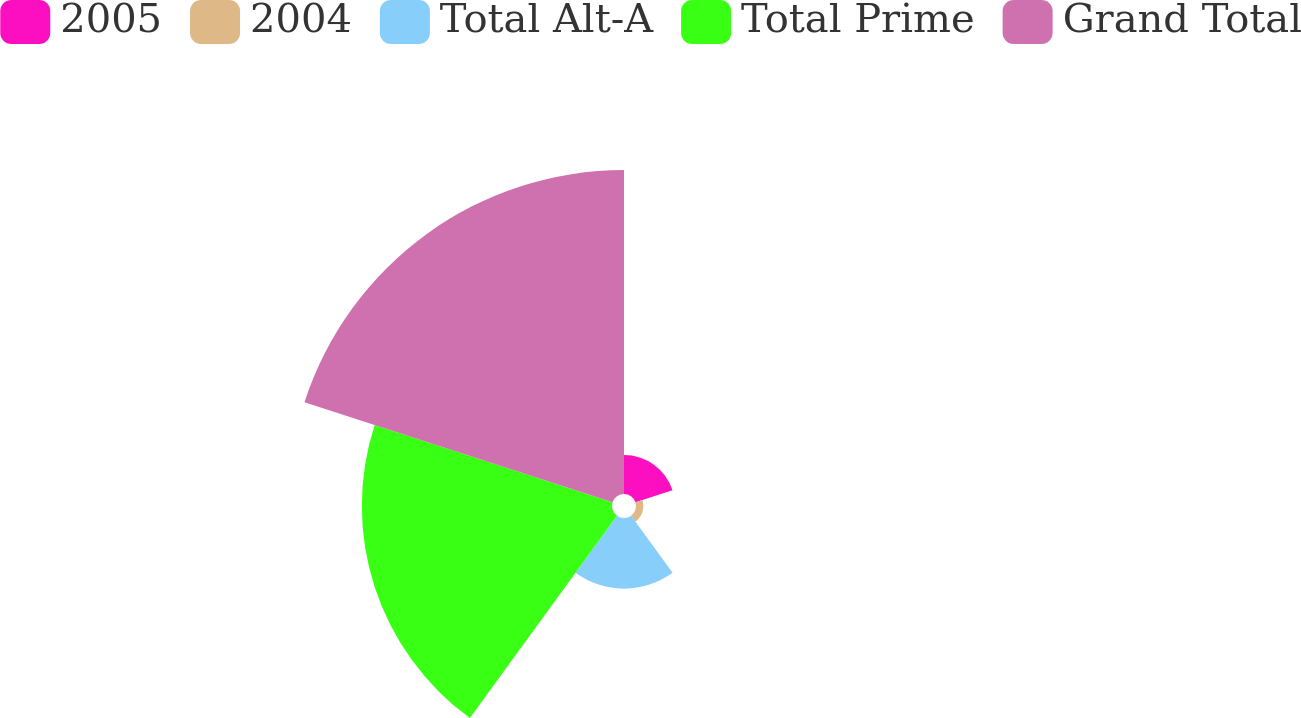Convert chart. <chart><loc_0><loc_0><loc_500><loc_500><pie_chart><fcel>2005<fcel>2004<fcel>Total Alt-A<fcel>Total Prime<fcel>Grand Total<nl><fcel>5.64%<fcel>1.06%<fcel>10.22%<fcel>36.2%<fcel>46.88%<nl></chart> 